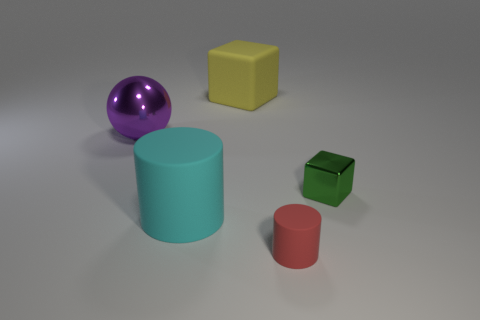What is the shape of the big thing in front of the large thing to the left of the large cylinder?
Your answer should be very brief. Cylinder. What number of things are purple spheres or tiny objects that are in front of the tiny green thing?
Offer a terse response. 2. How many other things are there of the same color as the matte cube?
Ensure brevity in your answer.  0. What number of yellow things are blocks or large rubber objects?
Your response must be concise. 1. Are there any large yellow rubber objects that are behind the rubber object that is behind the shiny thing that is right of the purple shiny ball?
Give a very brief answer. No. Is there any other thing that has the same size as the green metal cube?
Your response must be concise. Yes. Is the color of the small cube the same as the large cube?
Your answer should be compact. No. There is a rubber thing right of the cube that is on the left side of the tiny red matte object; what color is it?
Give a very brief answer. Red. How many large things are green blocks or purple things?
Offer a very short reply. 1. There is a large object that is behind the cyan matte cylinder and in front of the yellow rubber block; what is its color?
Provide a succinct answer. Purple. 